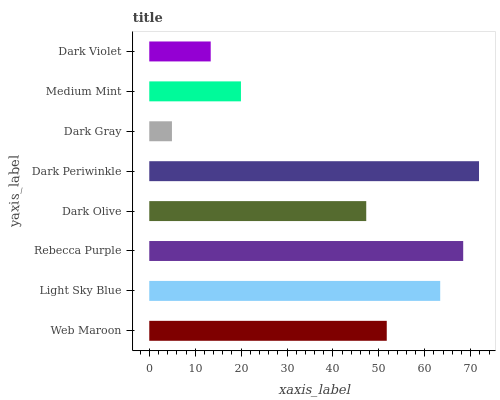Is Dark Gray the minimum?
Answer yes or no. Yes. Is Dark Periwinkle the maximum?
Answer yes or no. Yes. Is Light Sky Blue the minimum?
Answer yes or no. No. Is Light Sky Blue the maximum?
Answer yes or no. No. Is Light Sky Blue greater than Web Maroon?
Answer yes or no. Yes. Is Web Maroon less than Light Sky Blue?
Answer yes or no. Yes. Is Web Maroon greater than Light Sky Blue?
Answer yes or no. No. Is Light Sky Blue less than Web Maroon?
Answer yes or no. No. Is Web Maroon the high median?
Answer yes or no. Yes. Is Dark Olive the low median?
Answer yes or no. Yes. Is Dark Violet the high median?
Answer yes or no. No. Is Medium Mint the low median?
Answer yes or no. No. 